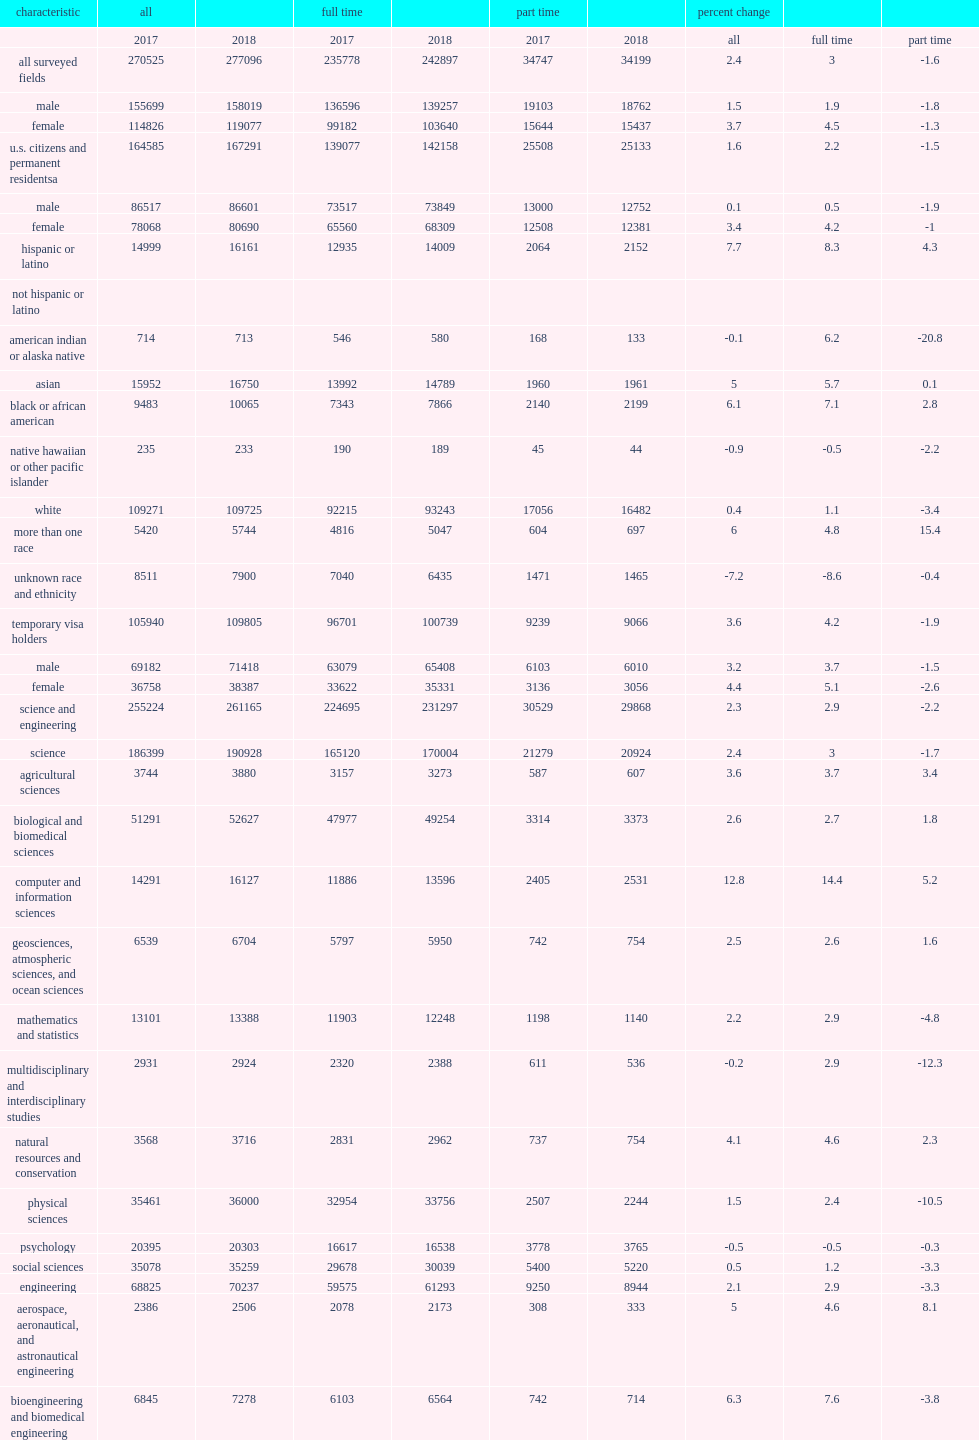Between 2017 and 2018, how many students did doctoral enrollment increase by among u.s. citizens and permanent residents? 2706. Between 2017 and 2018, how many students did doctoral enrollment increase by among temporary visa holders? 3865. 